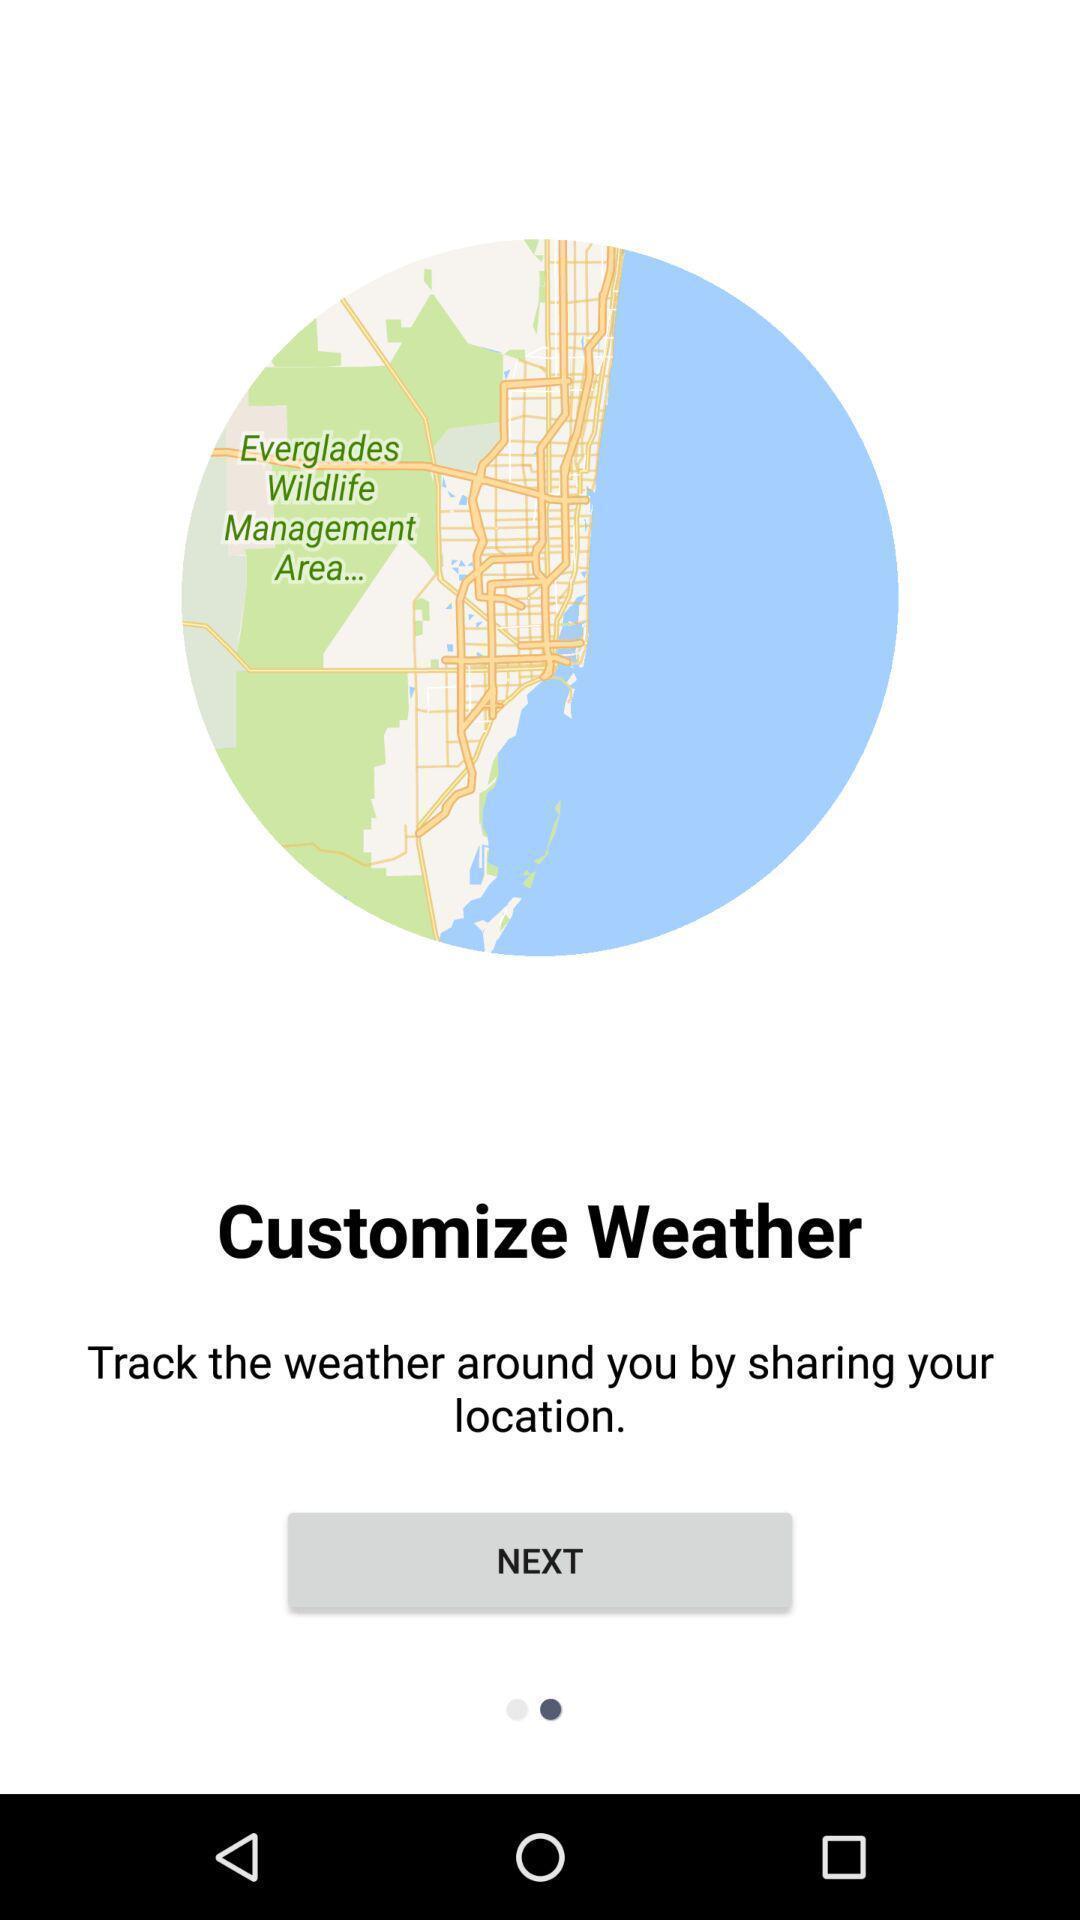Explain what's happening in this screen capture. Welcome page of a weather tracking app. 